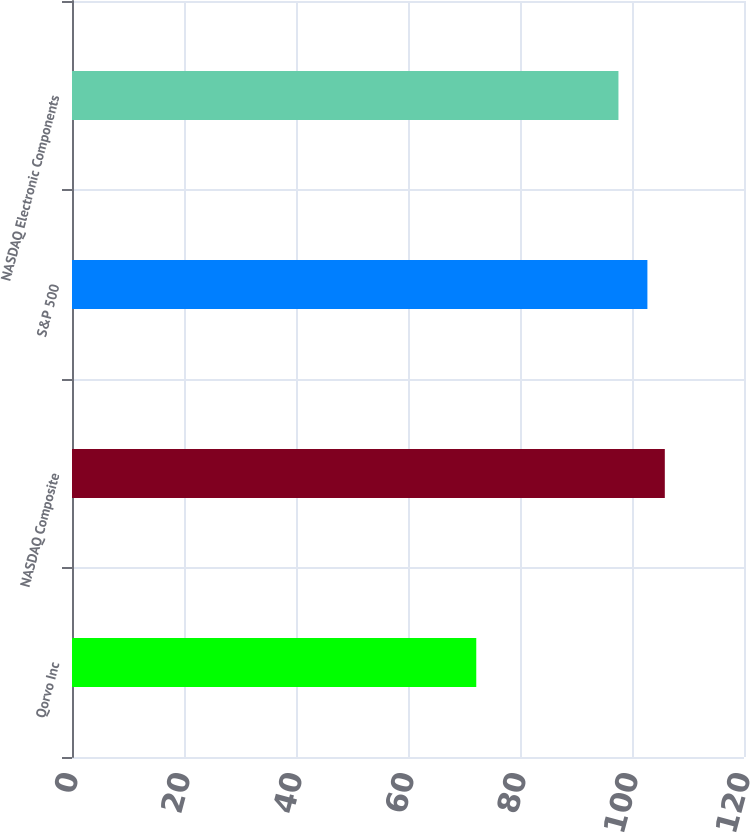<chart> <loc_0><loc_0><loc_500><loc_500><bar_chart><fcel>Qorvo Inc<fcel>NASDAQ Composite<fcel>S&P 500<fcel>NASDAQ Electronic Components<nl><fcel>72.19<fcel>105.86<fcel>102.75<fcel>97.58<nl></chart> 